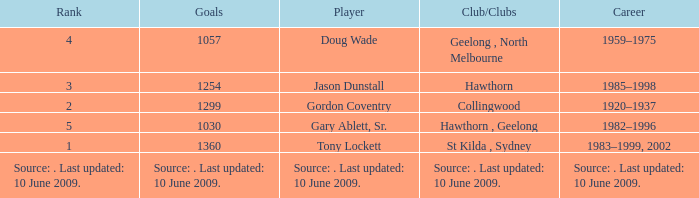Which player has 1299 goals? Gordon Coventry. 